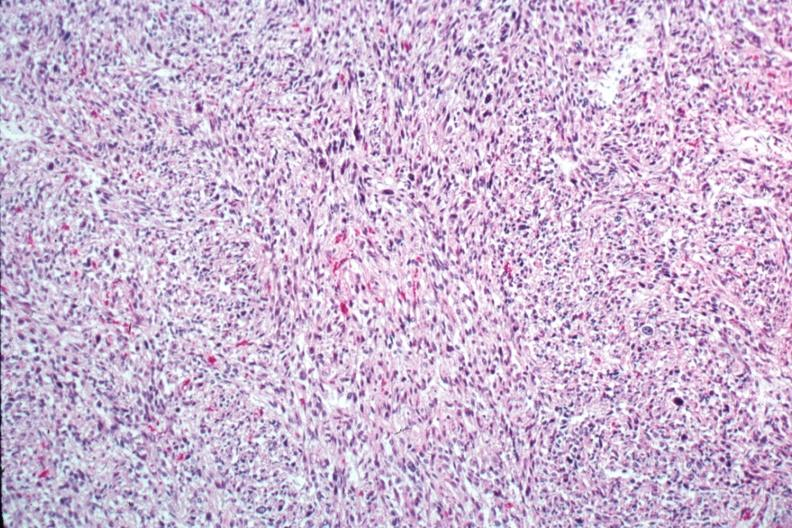what is present?
Answer the question using a single word or phrase. Female reproductive 